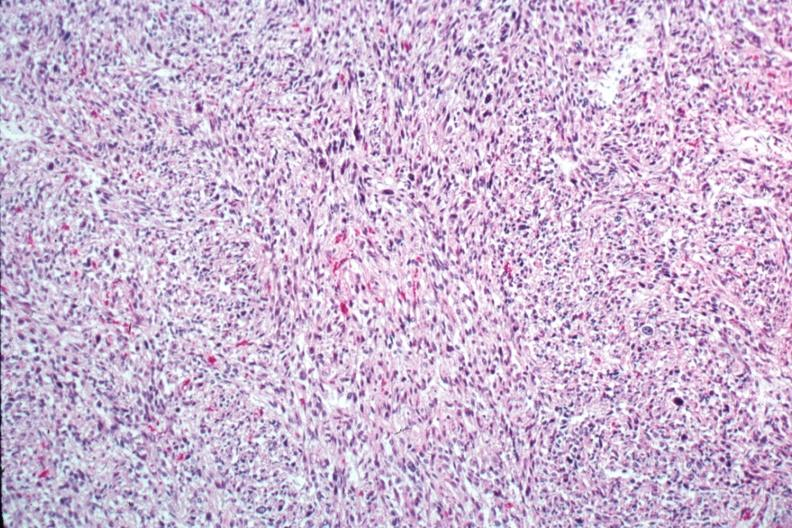what is present?
Answer the question using a single word or phrase. Female reproductive 